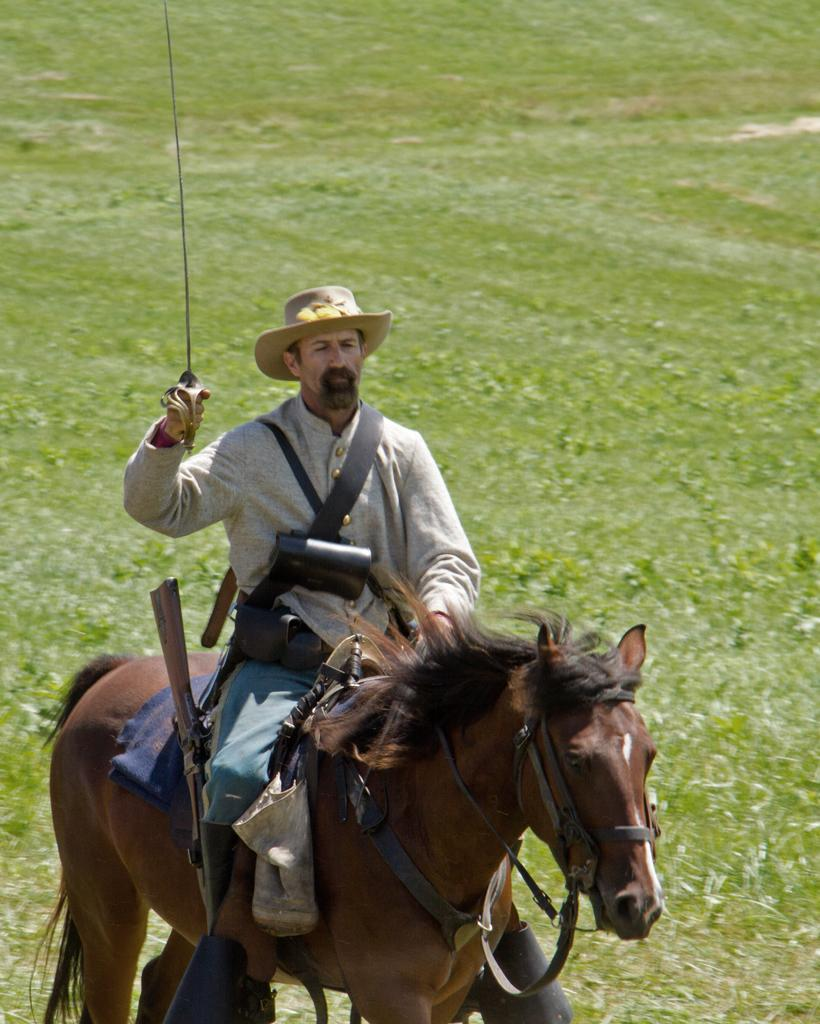Where was the image taken? The image is clicked outside the city. What is the main subject in the foreground of the image? There is a man in the foreground of the image. What is the man holding in the image? The man is holding a sword. What is the man doing in the image? The man is riding a horse. What type of vegetation can be seen in the background of the image? There is green grass visible in the background of the image. What shape is the oven in the image? There is no oven present in the image. What type of pen is the man using to write on the horse? The man is not using a pen in the image; he is holding a sword. 